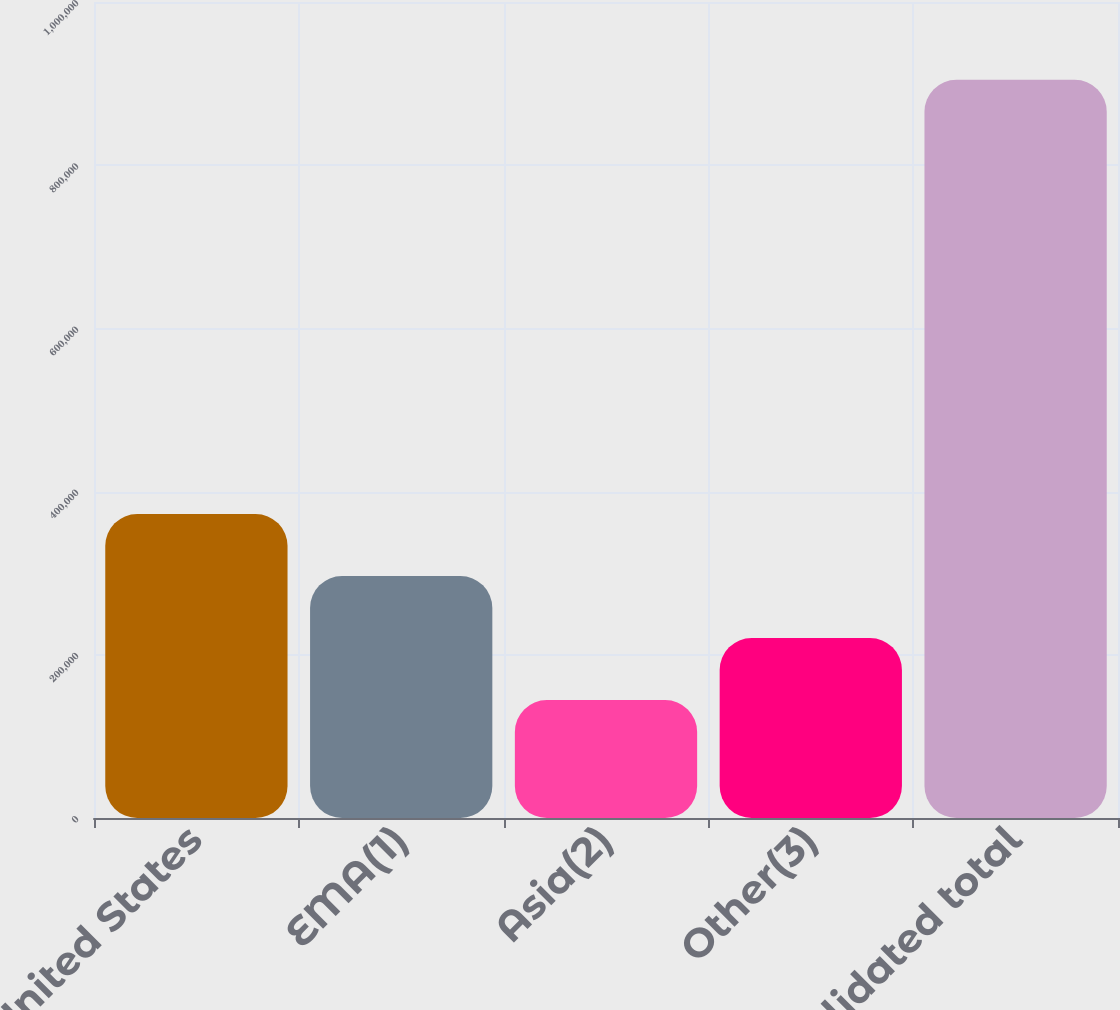<chart> <loc_0><loc_0><loc_500><loc_500><bar_chart><fcel>United States<fcel>EMA(1)<fcel>Asia(2)<fcel>Other(3)<fcel>Consolidated total<nl><fcel>372612<fcel>296608<fcel>144599<fcel>220603<fcel>904642<nl></chart> 